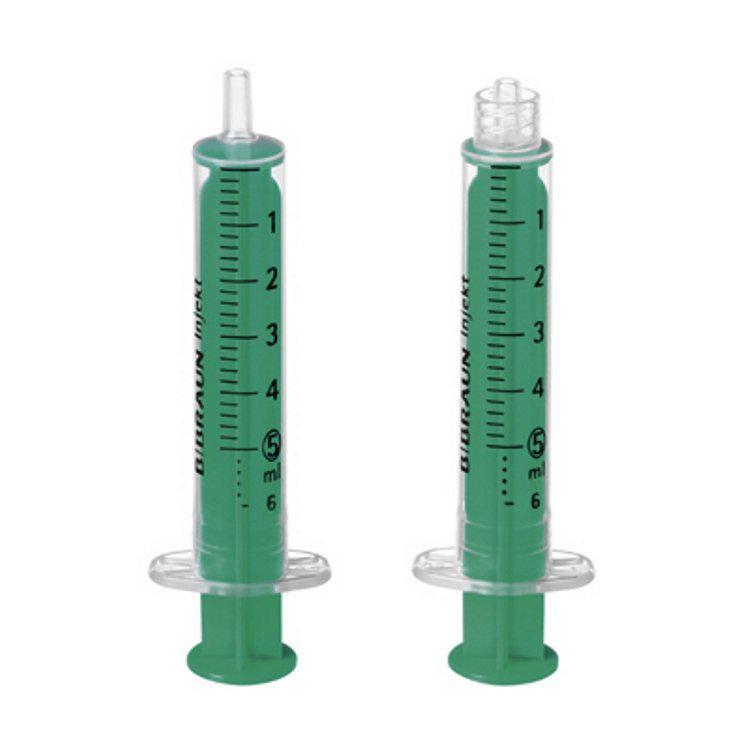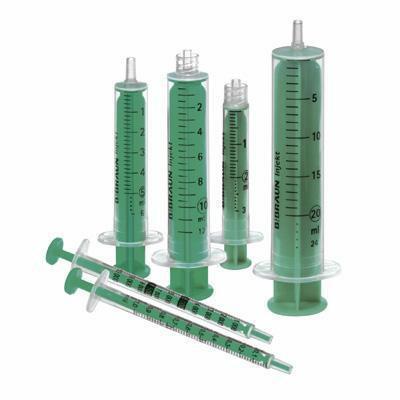The first image is the image on the left, the second image is the image on the right. For the images displayed, is the sentence "There are the same amount of syringes in the image on the left as in the image on the right." factually correct? Answer yes or no. No. The first image is the image on the left, the second image is the image on the right. Considering the images on both sides, is "Right and left images contain the same number of syringe-type items." valid? Answer yes or no. No. 